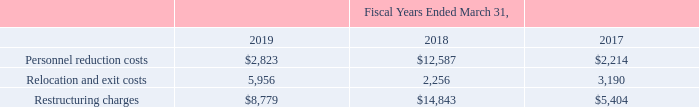KEMET CORPORATION AND SUBSIDIARIES
Notes to Consolidated Financial Statements (Continued)
A summary of the expenses aggregated on the Consolidated Statements of Operations line item “Restructuring charges” in the fiscal years ended March 31, 2019, 2018 and 2017, is as follows (amounts in thousands):
Fiscal Year Ended March 31, 2019
The Company incurred $8.8 million in restructuring charges in the fiscal year ended March 31, 2019, including $2.8 million in personnel reduction costs and $6.0 million in relocation and exit costs. The personnel reduction costs of $2.8 million were primarily due to $0.9 million in costs related to headcount reductions in the TOKIN legacy group across various internal and operational functions, $0.3 million in severance charges related to personnel reductions in the Film and Electrolytic reportable segment resulting from a reorganization of the segment's management structure, and $1.6 million in costs related to reorganization in the Solid Capacitors reportable segment due to a permanent structural change driven by a decline of MnO2 products. The relocation and exit costs of $6.0 million were primarily due to $3.4 million in costs related to the Company's relocation of its tantalum powder equipment from Carson City, Nevada to its plant in Matamoros, Mexico and $2.3 million in costs related to the relocation of axial electrolytic production equipment from Granna, Sweden to its plant in Evora, Portugal.
Fiscal Year Ended March 31, 2018
The Company incurred $14.8 million in restructuring charges in the fiscal year ended March 31, 2018, including $12.6 million related to personnel reduction costs and $2.3 million of relocation and exit costs. The personnel reduction costs of $12.6 million were due to $5.2 million related to a voluntary reduction in force in the Film and Electrolytic reportable segment's Italian operations; $4.4 million related to a headcount reduction in the TOKIN legacy group across various internal and operational functions; $2.7 million in severance charges across various overhead functions in the Simpsonville, South Carolina office as these functions were relocated to the Company's new corporate headquarters in Fort Lauderdale, Florida; and $0.2 million in headcount reductions related to a European sales reorganization. The relocation and exit costs of $2.3 million included $0.9 million in lease termination penalties related to the relocation of global marketing, finance and accounting, and information technology functions to the Company's Fort Lauderdale office, $0.8 million in expenses related to the relocation of the K-Salt operations to the existing Matamoros, Mexico plant, $0.4 million in exit costs related to the shut-down of operations for KFM, and $0.1 million related to the transfer of certain Tantalum production from Simpsonville, South Carolina to Victoria, Mexico.
Fiscal Year Ended March 31, 2017
The Company incurred $5.4 million in restructuring charges in the fiscal year ended March 31, 2017, including $2.2 million related to personnel reduction costs and $3.2 million of relocation and exit costs. The personnel reduction costs of $2.2 million corresponded with the following: $0.3 million related to the consolidation of certain Solid Capacitor manufacturing in Matamoros, Mexico; $0.4 million for headcount reductions related to the shut-down of operations for KFM; $0.3 million related to headcount reductions in Europe (primarily Italy and Landsberg, Germany) corresponding with the relocation of certain production lines and laboratories to lower cost regions; $0.3 million for overhead reductions in Sweden; $0.3 million in U.S. headcount reductions related to the relocation of global marketing functions to the Company’s Fort Lauderdale, Florida office; $0.3 million in headcount reductions related to the transfer of certain Tantalum production from Simpsonville, South Carolina to Victoria, Mexico; $0.2 million in overhead reductions for the relocation of research and development operations from Weymouth, England to Evora, Portugal; and $0.1 million in manufacturing headcount reductions related to the relocation of the K-Salt operations to the existing Matamoros, Mexico plant. The relocation and exit costs of $3.2 million included $1.9 million in expenses related to contract termination costs related to the shut-down of operations for KFM; $0.6 million in expenses related to the relocation of the K-Salt operations to the existing Matamoros, Mexico plant; $0.6 million for transfers of Film and Electrolytic production lines and R&D functions to lower cost regions; and $0.1 million related to the transfer of certain Tantalum production from Simpsonville, South Carolina to Victoria, Mexico.
Which years does the table provide information for expenses aggregated on the Consolidated Statements of Operations line item “Restructuring charges"? 2019, 2018, 2017. What were the relocation and exit costs in 2017?
Answer scale should be: thousand. 3,190. What were the restructuring charges in 2019?
Answer scale should be: thousand. 8,779. How many years did restructuring charges exceed $10,000 thousand? 2018
Answer: 1. What was the change in Personnel reduction costs between 2017 and 2018?
Answer scale should be: thousand. 12,587-2,214
Answer: 10373. What was the percentage change in the Relocation and exit costs between 2018 and 2019?
Answer scale should be: percent. (5,956-2,256)/2,256
Answer: 164.01. 